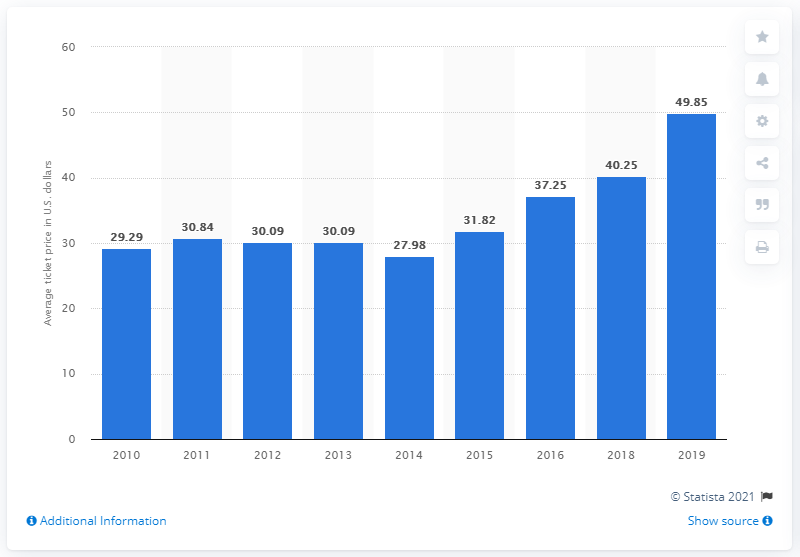Point out several critical features in this image. The average ticket price for Houston Astros games in 2019 was $49.85. 